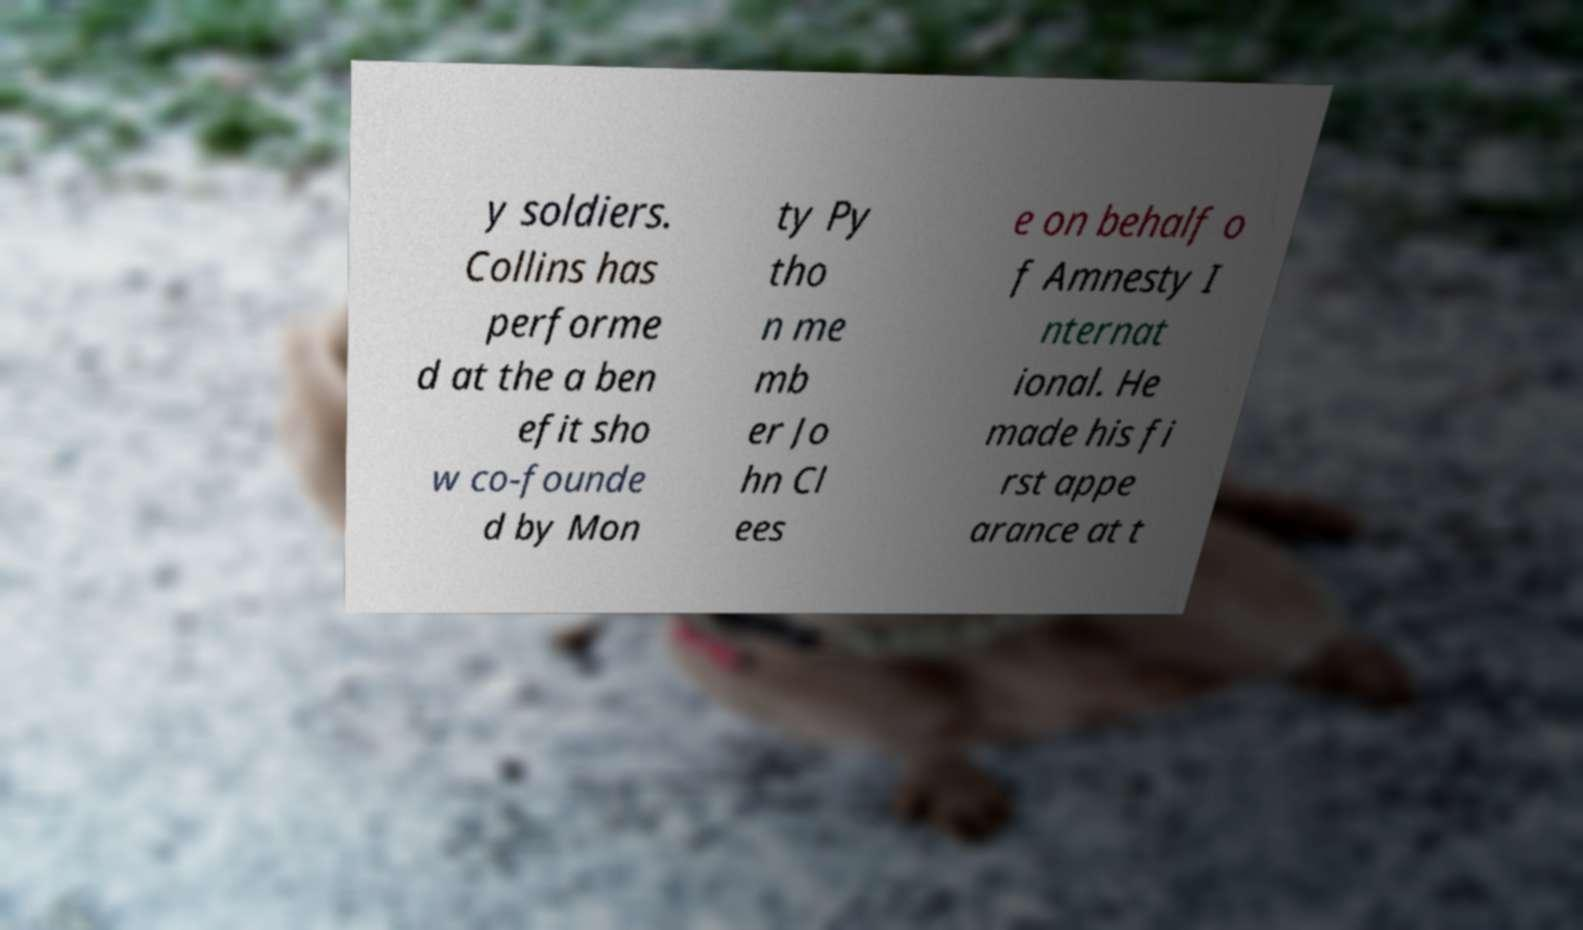Can you read and provide the text displayed in the image?This photo seems to have some interesting text. Can you extract and type it out for me? y soldiers. Collins has performe d at the a ben efit sho w co-founde d by Mon ty Py tho n me mb er Jo hn Cl ees e on behalf o f Amnesty I nternat ional. He made his fi rst appe arance at t 